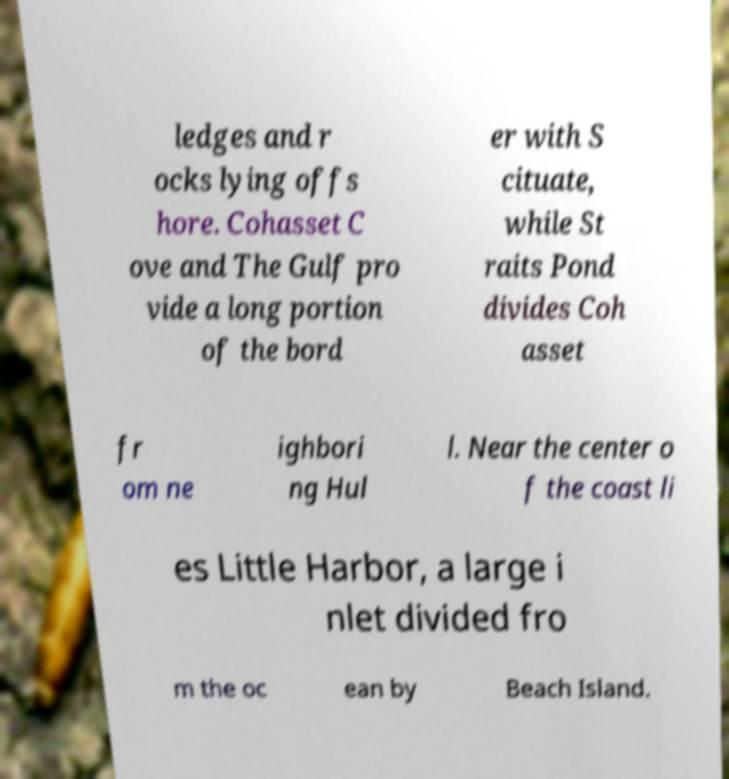Please read and relay the text visible in this image. What does it say? ledges and r ocks lying offs hore. Cohasset C ove and The Gulf pro vide a long portion of the bord er with S cituate, while St raits Pond divides Coh asset fr om ne ighbori ng Hul l. Near the center o f the coast li es Little Harbor, a large i nlet divided fro m the oc ean by Beach Island. 